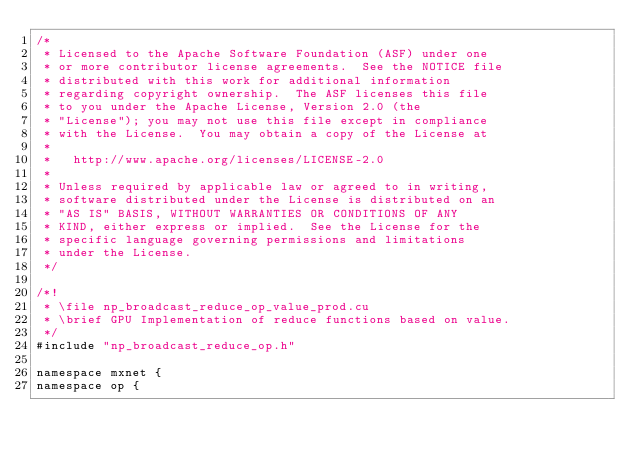<code> <loc_0><loc_0><loc_500><loc_500><_Cuda_>/*
 * Licensed to the Apache Software Foundation (ASF) under one
 * or more contributor license agreements.  See the NOTICE file
 * distributed with this work for additional information
 * regarding copyright ownership.  The ASF licenses this file
 * to you under the Apache License, Version 2.0 (the
 * "License"); you may not use this file except in compliance
 * with the License.  You may obtain a copy of the License at
 *
 *   http://www.apache.org/licenses/LICENSE-2.0
 *
 * Unless required by applicable law or agreed to in writing,
 * software distributed under the License is distributed on an
 * "AS IS" BASIS, WITHOUT WARRANTIES OR CONDITIONS OF ANY
 * KIND, either express or implied.  See the License for the
 * specific language governing permissions and limitations
 * under the License.
 */

/*!
 * \file np_broadcast_reduce_op_value_prod.cu
 * \brief GPU Implementation of reduce functions based on value.
 */
#include "np_broadcast_reduce_op.h"

namespace mxnet {
namespace op {
</code> 